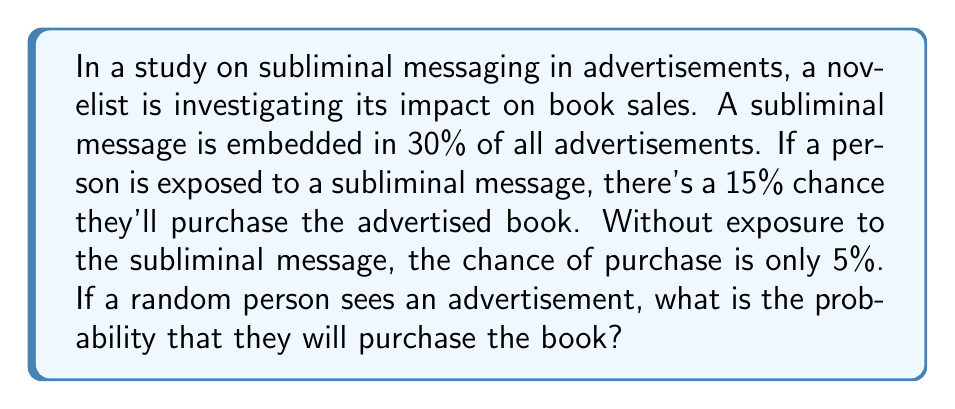Give your solution to this math problem. Let's approach this step-by-step using probability theory:

1) Define events:
   A: Advertisement contains subliminal message
   B: Person purchases the book

2) Given probabilities:
   $P(A) = 0.30$ (30% of ads contain subliminal message)
   $P(B|A) = 0.15$ (15% chance of purchase if exposed to subliminal message)
   $P(B|\text{not }A) = 0.05$ (5% chance of purchase if not exposed to subliminal message)

3) We need to find $P(B)$, the total probability of purchasing the book.

4) Use the Law of Total Probability:
   $$P(B) = P(B|A) \cdot P(A) + P(B|\text{not }A) \cdot P(\text{not }A)$$

5) Calculate $P(\text{not }A)$:
   $P(\text{not }A) = 1 - P(A) = 1 - 0.30 = 0.70$

6) Substitute values into the equation:
   $$P(B) = 0.15 \cdot 0.30 + 0.05 \cdot 0.70$$

7) Calculate:
   $$P(B) = 0.045 + 0.035 = 0.08$$

Thus, the probability that a random person who sees an advertisement will purchase the book is 0.08 or 8%.
Answer: 0.08 